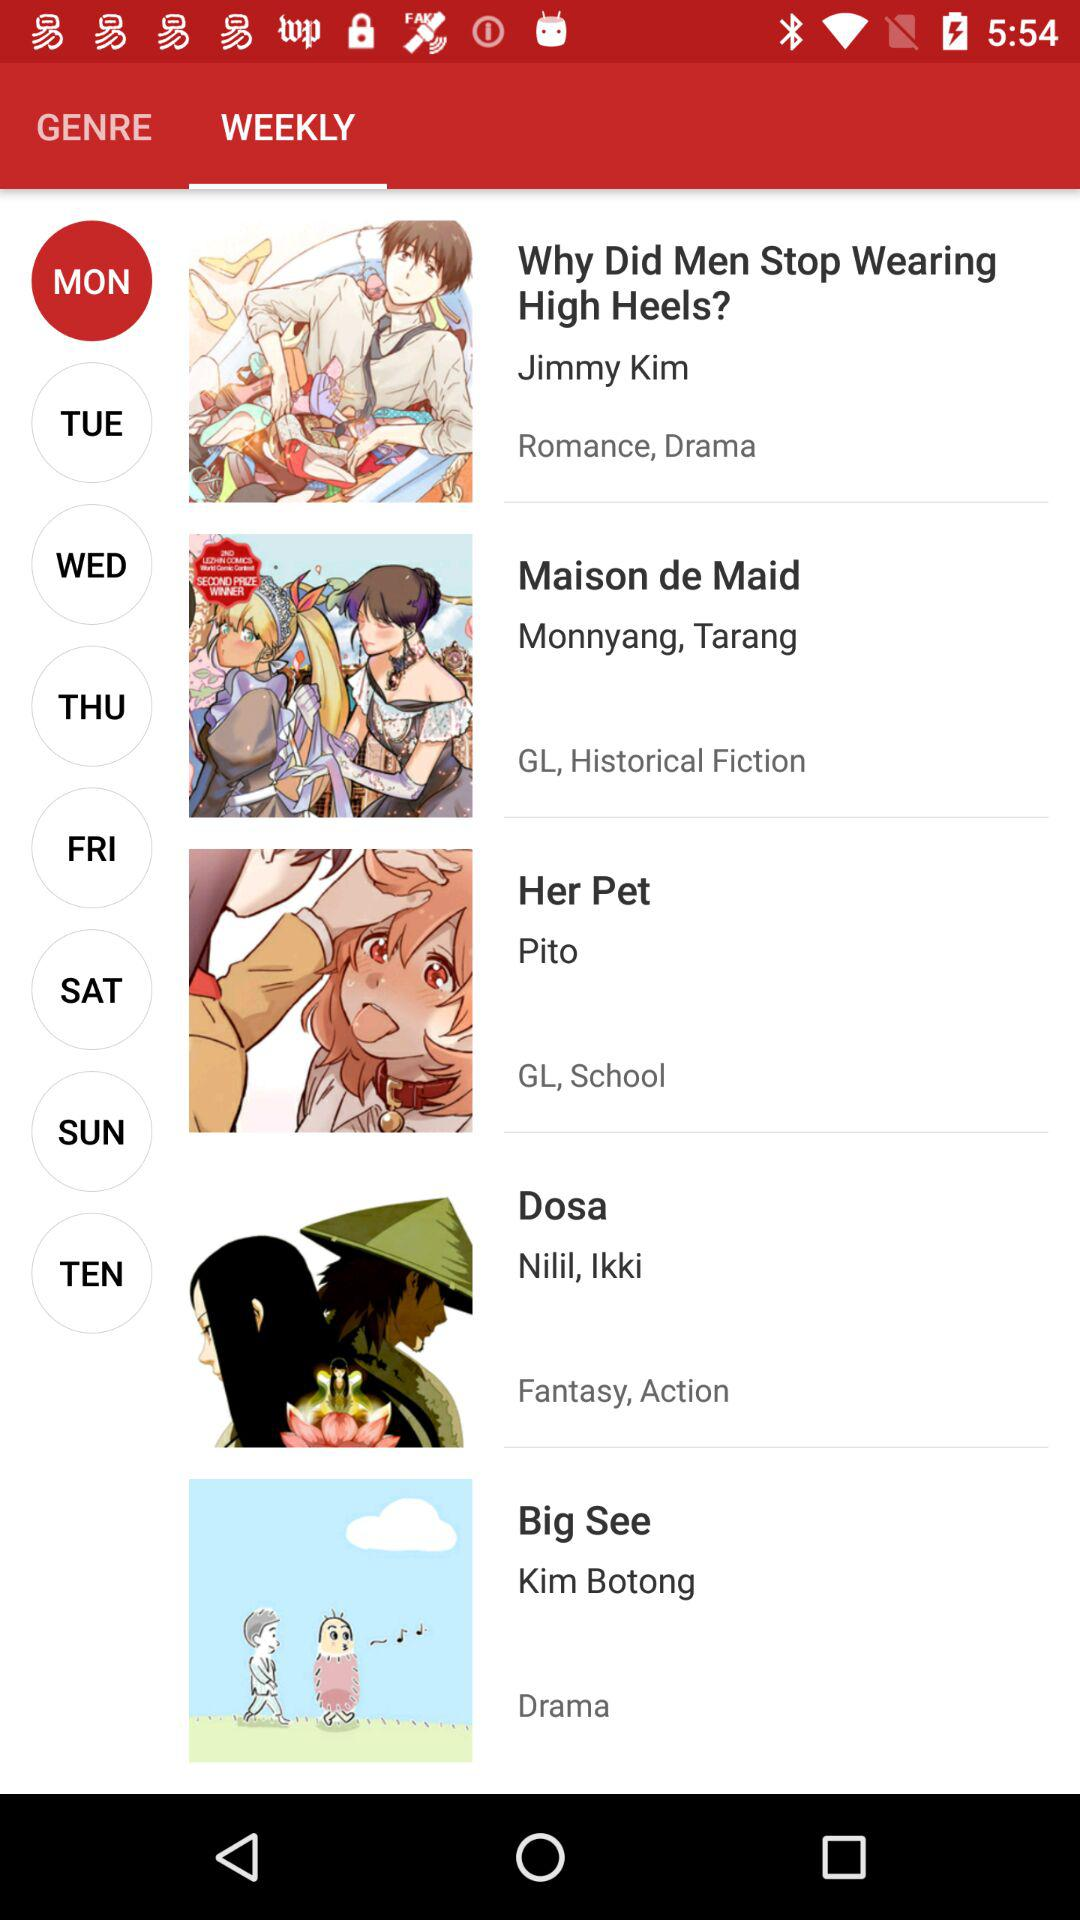Which day is selected? The selected day is Monday. 